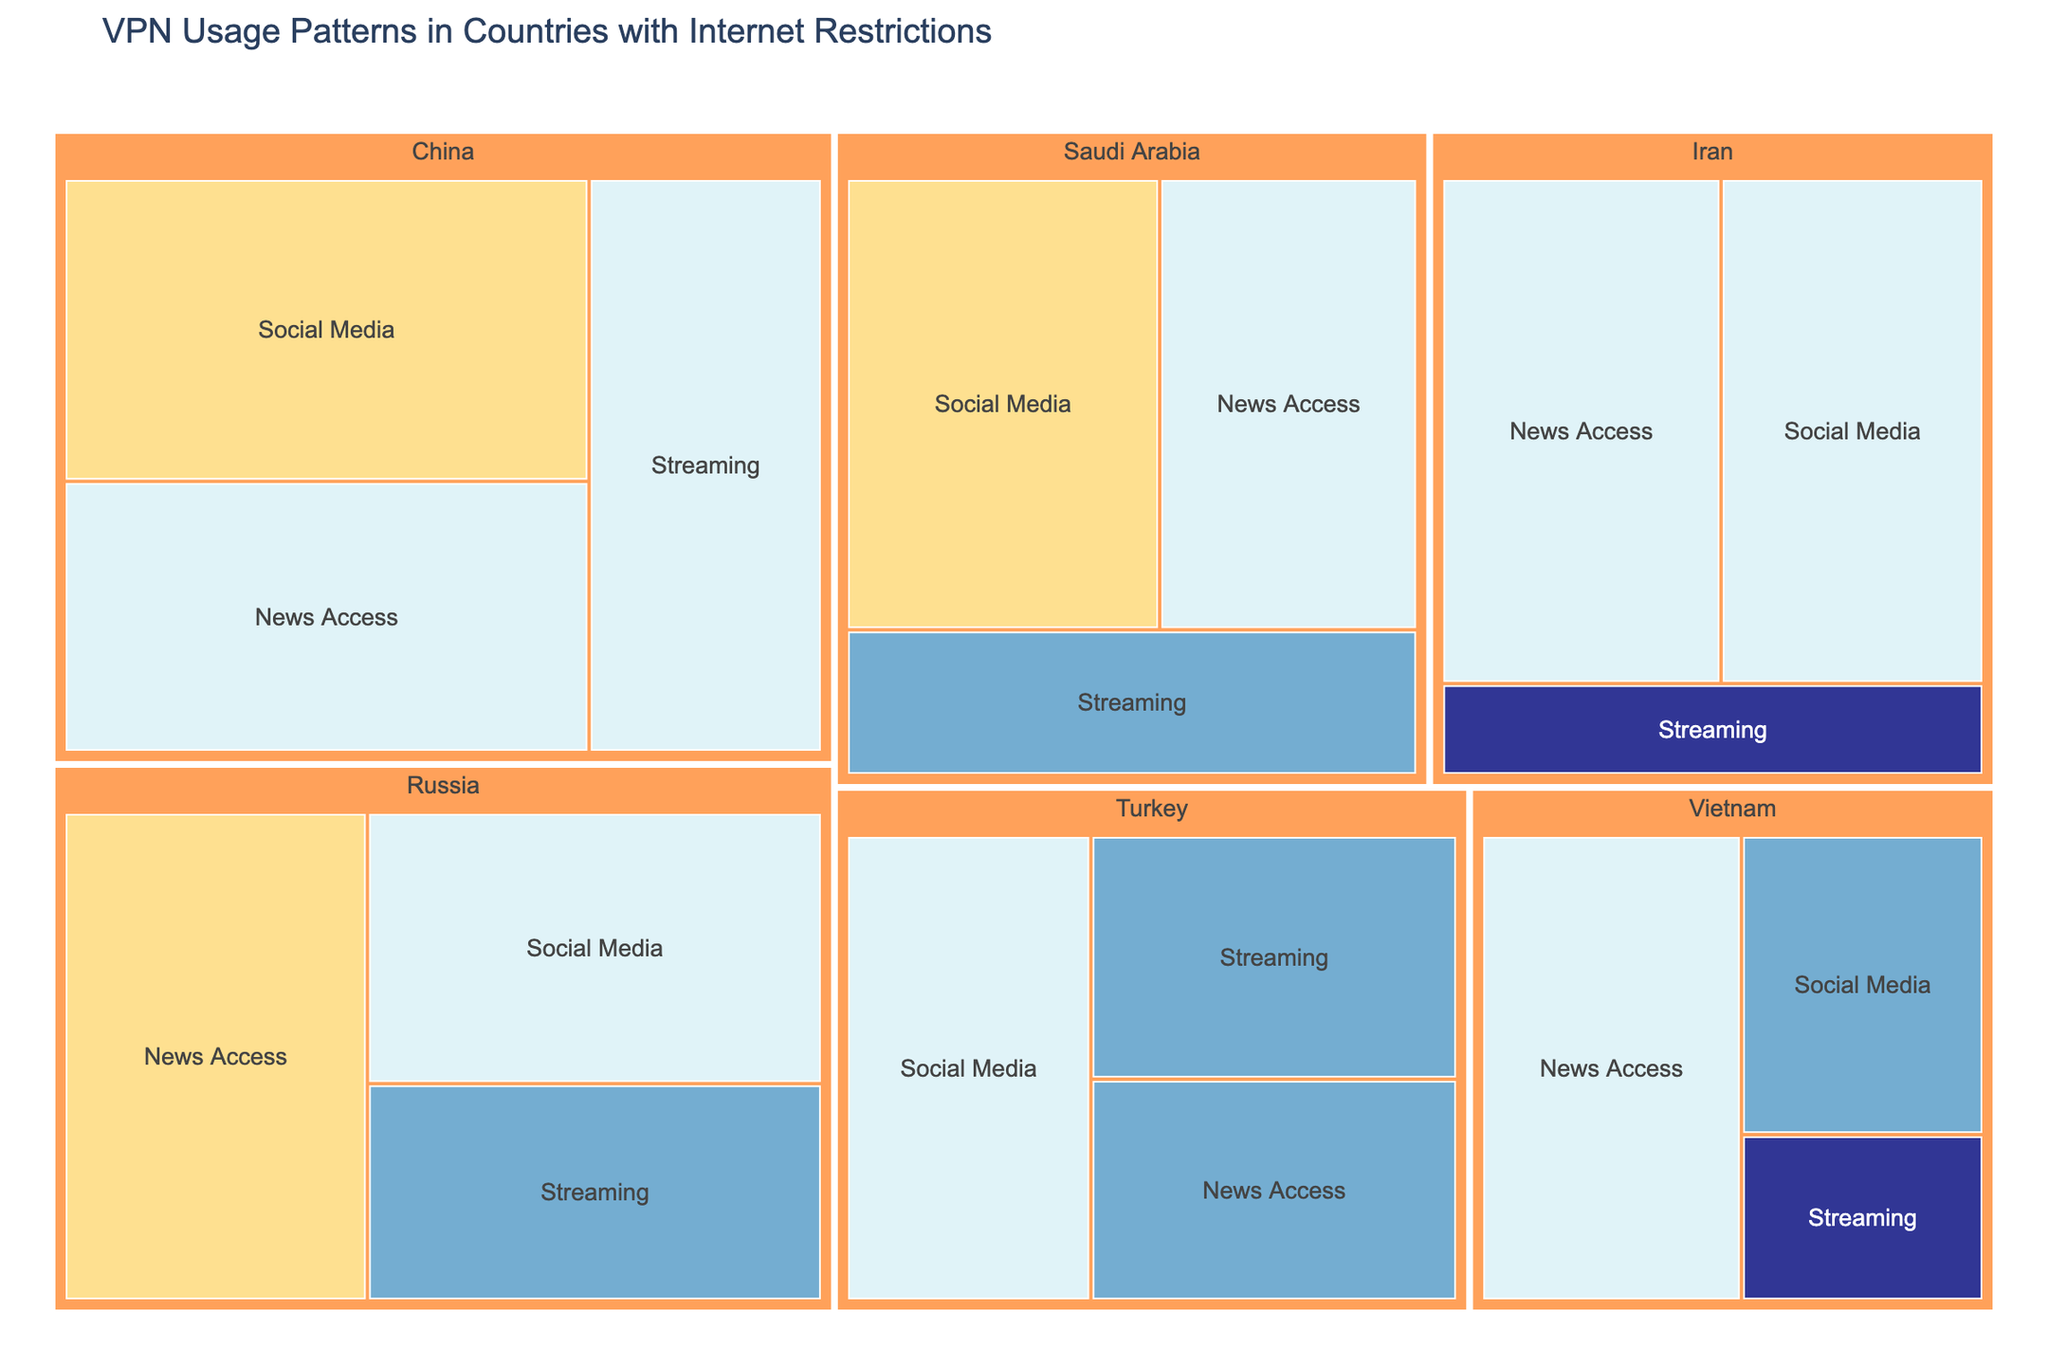What's the title of the Treemap? The title is usually located above the Treemap and provides a brief description of what the figure represents. Here, it reads, "VPN Usage Patterns in Countries with Internet Restrictions."
Answer: VPN Usage Patterns in Countries with Internet Restrictions Which country has the highest value for Social Media usage? The Treemap shows several countries with their categories clearly labeled. For Social Media, the highest value is in China with a value of 95.
Answer: China What is the total value of VPN usage in Russia? To find the total value, sum up the values for all categories in Russia: Streaming (60) + Social Media (75) + News Access (90). The total is 60 + 75 + 90 = 225.
Answer: 225 Which category has the lowest VPN usage value in Vietnam? For Vietnam, the Treemap clearly labels the categories. The Streaming category has the lowest value at 25.
Answer: Streaming Compare the VPN usage values for Streaming between Iran and Turkey. Which country has higher usage and by how much? To compare, look at the values for Streaming in both countries: Iran (30) and Turkey (55). Turkey has higher usage by 55 - 30 = 25.
Answer: Turkey by 25 Which country has the most balanced usage values across all categories? To determine balance, look at the variation in values across the categories for each country. Turkey has relatively balanced values: Streaming (55), Social Media (70), News Access (50). The differences among these values are smaller compared to other countries.
Answer: Turkey What is the average VPN usage value for Social Media across all countries? To find the average, sum up all Social Media values and divide by the number of countries: (95 + 75 + 80 + 70 + 45 + 85) / 6. The sum is 450, and the number of countries is 6, so the average is 450 / 6 = 75.
Answer: 75 In the Treemap, which category has the most instances of "Very High" usage? Look at the color indicating "Very High" usage across all categories. Social Media appears as "Very High" in China and Saudi Arabia. This category has the most instances with 2.
Answer: Social Media What proportion of China’s total value is attributed to News Access? To find this proportion, divide the News Access value for China by the total value for China: 85 / (80 + 95 + 85). The total is 260, so the proportion is 85 / 260 ≈ 0.326 or 32.6%.
Answer: 32.6% Which country has the highest value for News Access, and what is that value? The Treemap displays that Russia has the highest value for News Access with a value of 90.
Answer: Russia 